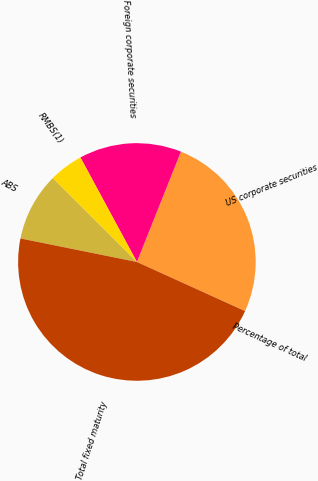<chart> <loc_0><loc_0><loc_500><loc_500><pie_chart><fcel>US corporate securities<fcel>Foreign corporate securities<fcel>RMBS(1)<fcel>ABS<fcel>Total fixed maturity<fcel>Percentage of total<nl><fcel>25.72%<fcel>13.93%<fcel>4.65%<fcel>9.29%<fcel>46.39%<fcel>0.01%<nl></chart> 